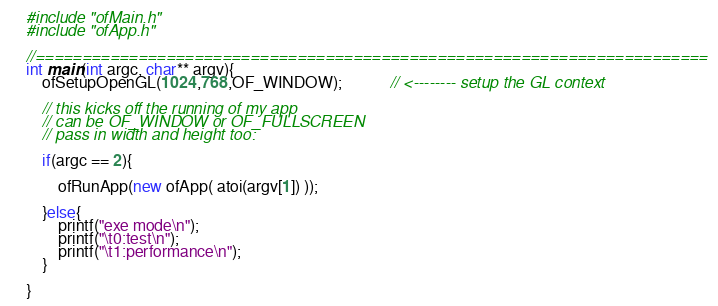Convert code to text. <code><loc_0><loc_0><loc_500><loc_500><_C++_>#include "ofMain.h"
#include "ofApp.h"

//========================================================================
int main(int argc, char** argv){
	ofSetupOpenGL(1024,768,OF_WINDOW);			// <-------- setup the GL context

	// this kicks off the running of my app
	// can be OF_WINDOW or OF_FULLSCREEN
	// pass in width and height too:
	
	if(argc == 2){
		
		ofRunApp(new ofApp( atoi(argv[1]) ));
		
	}else{
		printf("exe mode\n");
		printf("\t0:test\n");
		printf("\t1:performance\n");
	}

}
</code> 